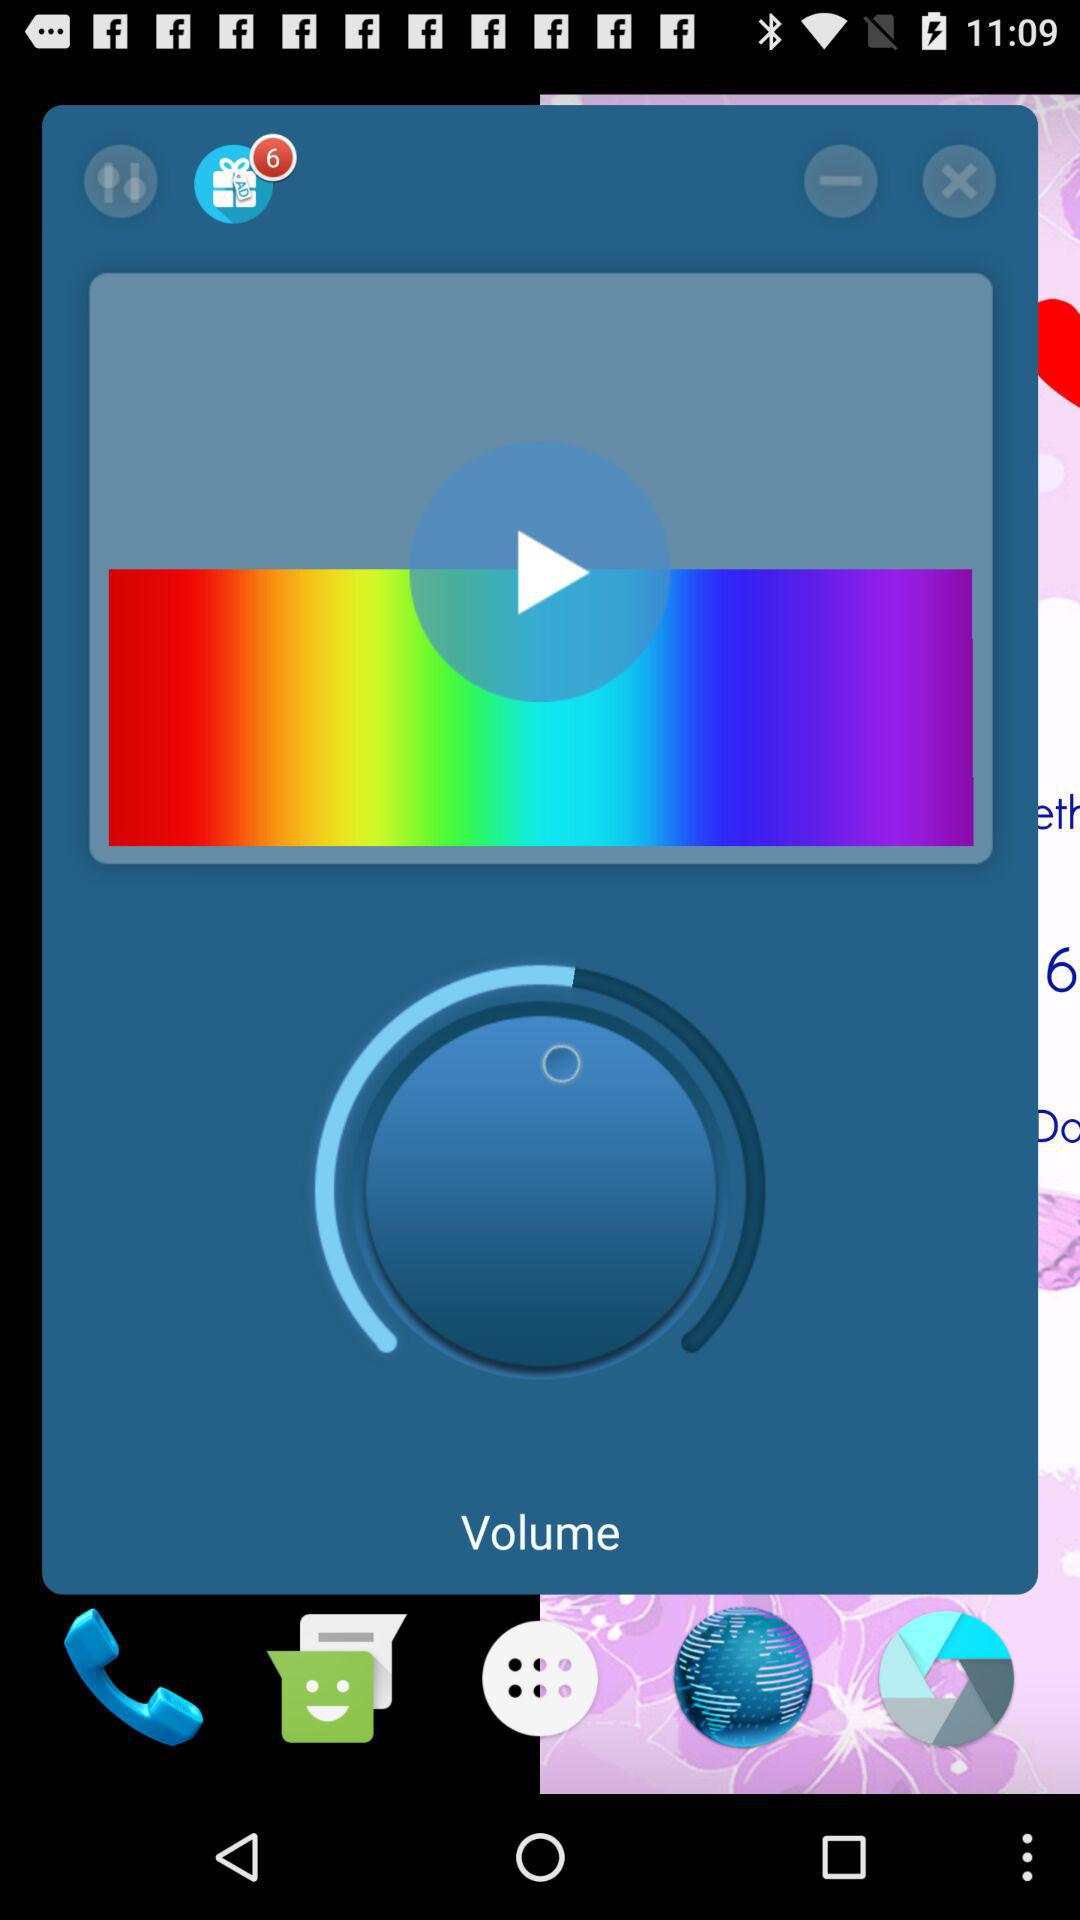How many unread notifications are there? There are 6 unread notifications. 